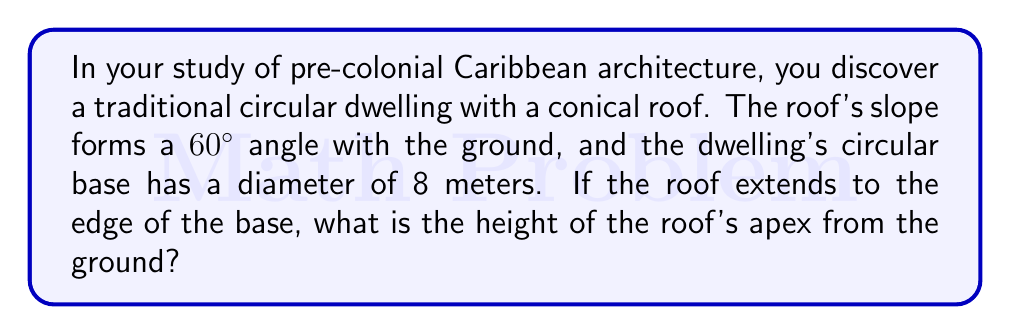What is the answer to this math problem? Let's approach this step-by-step:

1) First, we need to visualize the problem. The dwelling forms a right circular cone, where:
   - The base radius is half the diameter: $r = 4$ meters
   - The angle between the roof and the ground is 60°

2) In a right-angled triangle formed by the roof's slope:
   - The angle at the base is 60°
   - The adjacent side is the base radius (4 meters)
   - The opposite side is the height we're looking for (let's call it $h$)

3) We can use the tangent function to find the height:

   $$\tan 60° = \frac{\text{opposite}}{\text{adjacent}} = \frac{h}{4}$$

4) We know that $\tan 60° = \sqrt{3}$, so:

   $$\sqrt{3} = \frac{h}{4}$$

5) Solving for $h$:

   $$h = 4\sqrt{3}$$

6) To get a decimal approximation:

   $$h \approx 4 * 1.732 \approx 6.928 \text{ meters}$$

Therefore, the height of the roof's apex from the ground is $4\sqrt{3}$ meters, or approximately 6.928 meters.
Answer: $4\sqrt{3}$ meters 